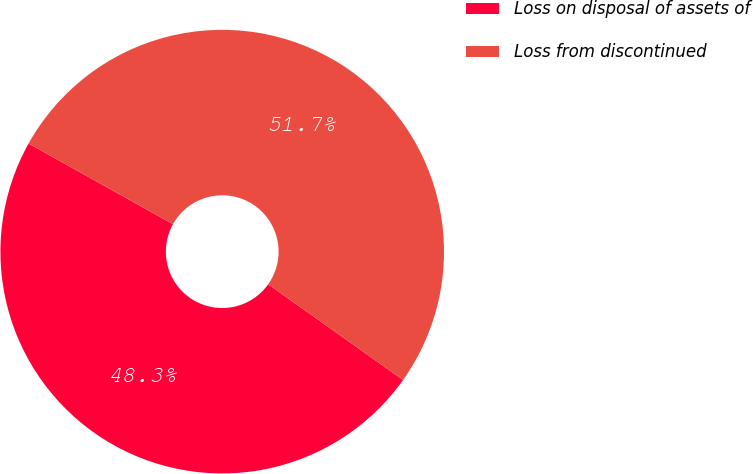<chart> <loc_0><loc_0><loc_500><loc_500><pie_chart><fcel>Loss on disposal of assets of<fcel>Loss from discontinued<nl><fcel>48.28%<fcel>51.72%<nl></chart> 